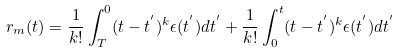Convert formula to latex. <formula><loc_0><loc_0><loc_500><loc_500>r _ { m } ( t ) = \frac { 1 } { k ! } \int _ { T } ^ { 0 } ( t - t ^ { ^ { \prime } } ) ^ { k } \epsilon ( t ^ { ^ { \prime } } ) d t ^ { ^ { \prime } } + \frac { 1 } { k ! } \int _ { 0 } ^ { t } ( t - t ^ { ^ { \prime } } ) ^ { k } \epsilon ( t ^ { ^ { \prime } } ) d t ^ { ^ { \prime } }</formula> 